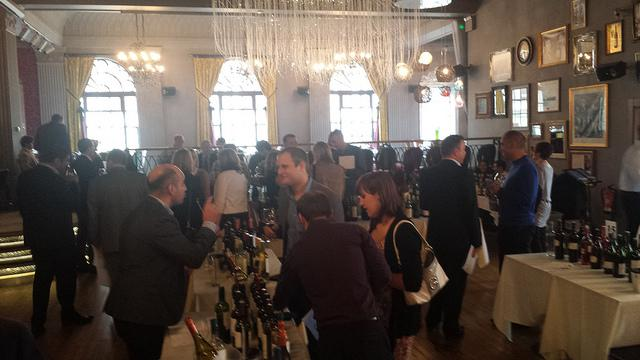New Orleans is inventor of what? Please explain your reasoning. cocktail. There is an unverified claim it was this product 